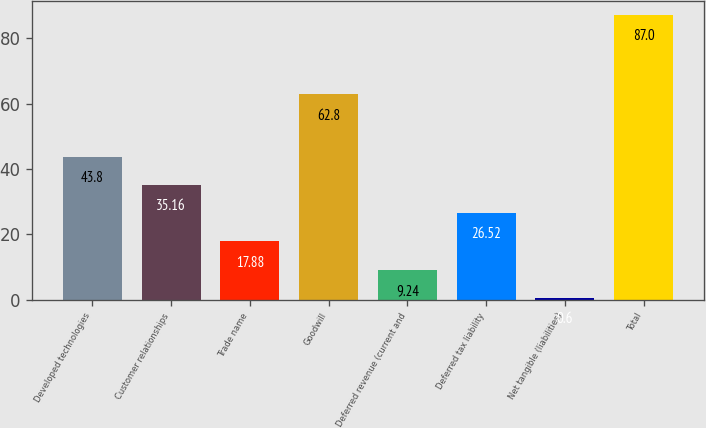Convert chart. <chart><loc_0><loc_0><loc_500><loc_500><bar_chart><fcel>Developed technologies<fcel>Customer relationships<fcel>Trade name<fcel>Goodwill<fcel>Deferred revenue (current and<fcel>Deferred tax liability<fcel>Net tangible (liabilities)<fcel>Total<nl><fcel>43.8<fcel>35.16<fcel>17.88<fcel>62.8<fcel>9.24<fcel>26.52<fcel>0.6<fcel>87<nl></chart> 